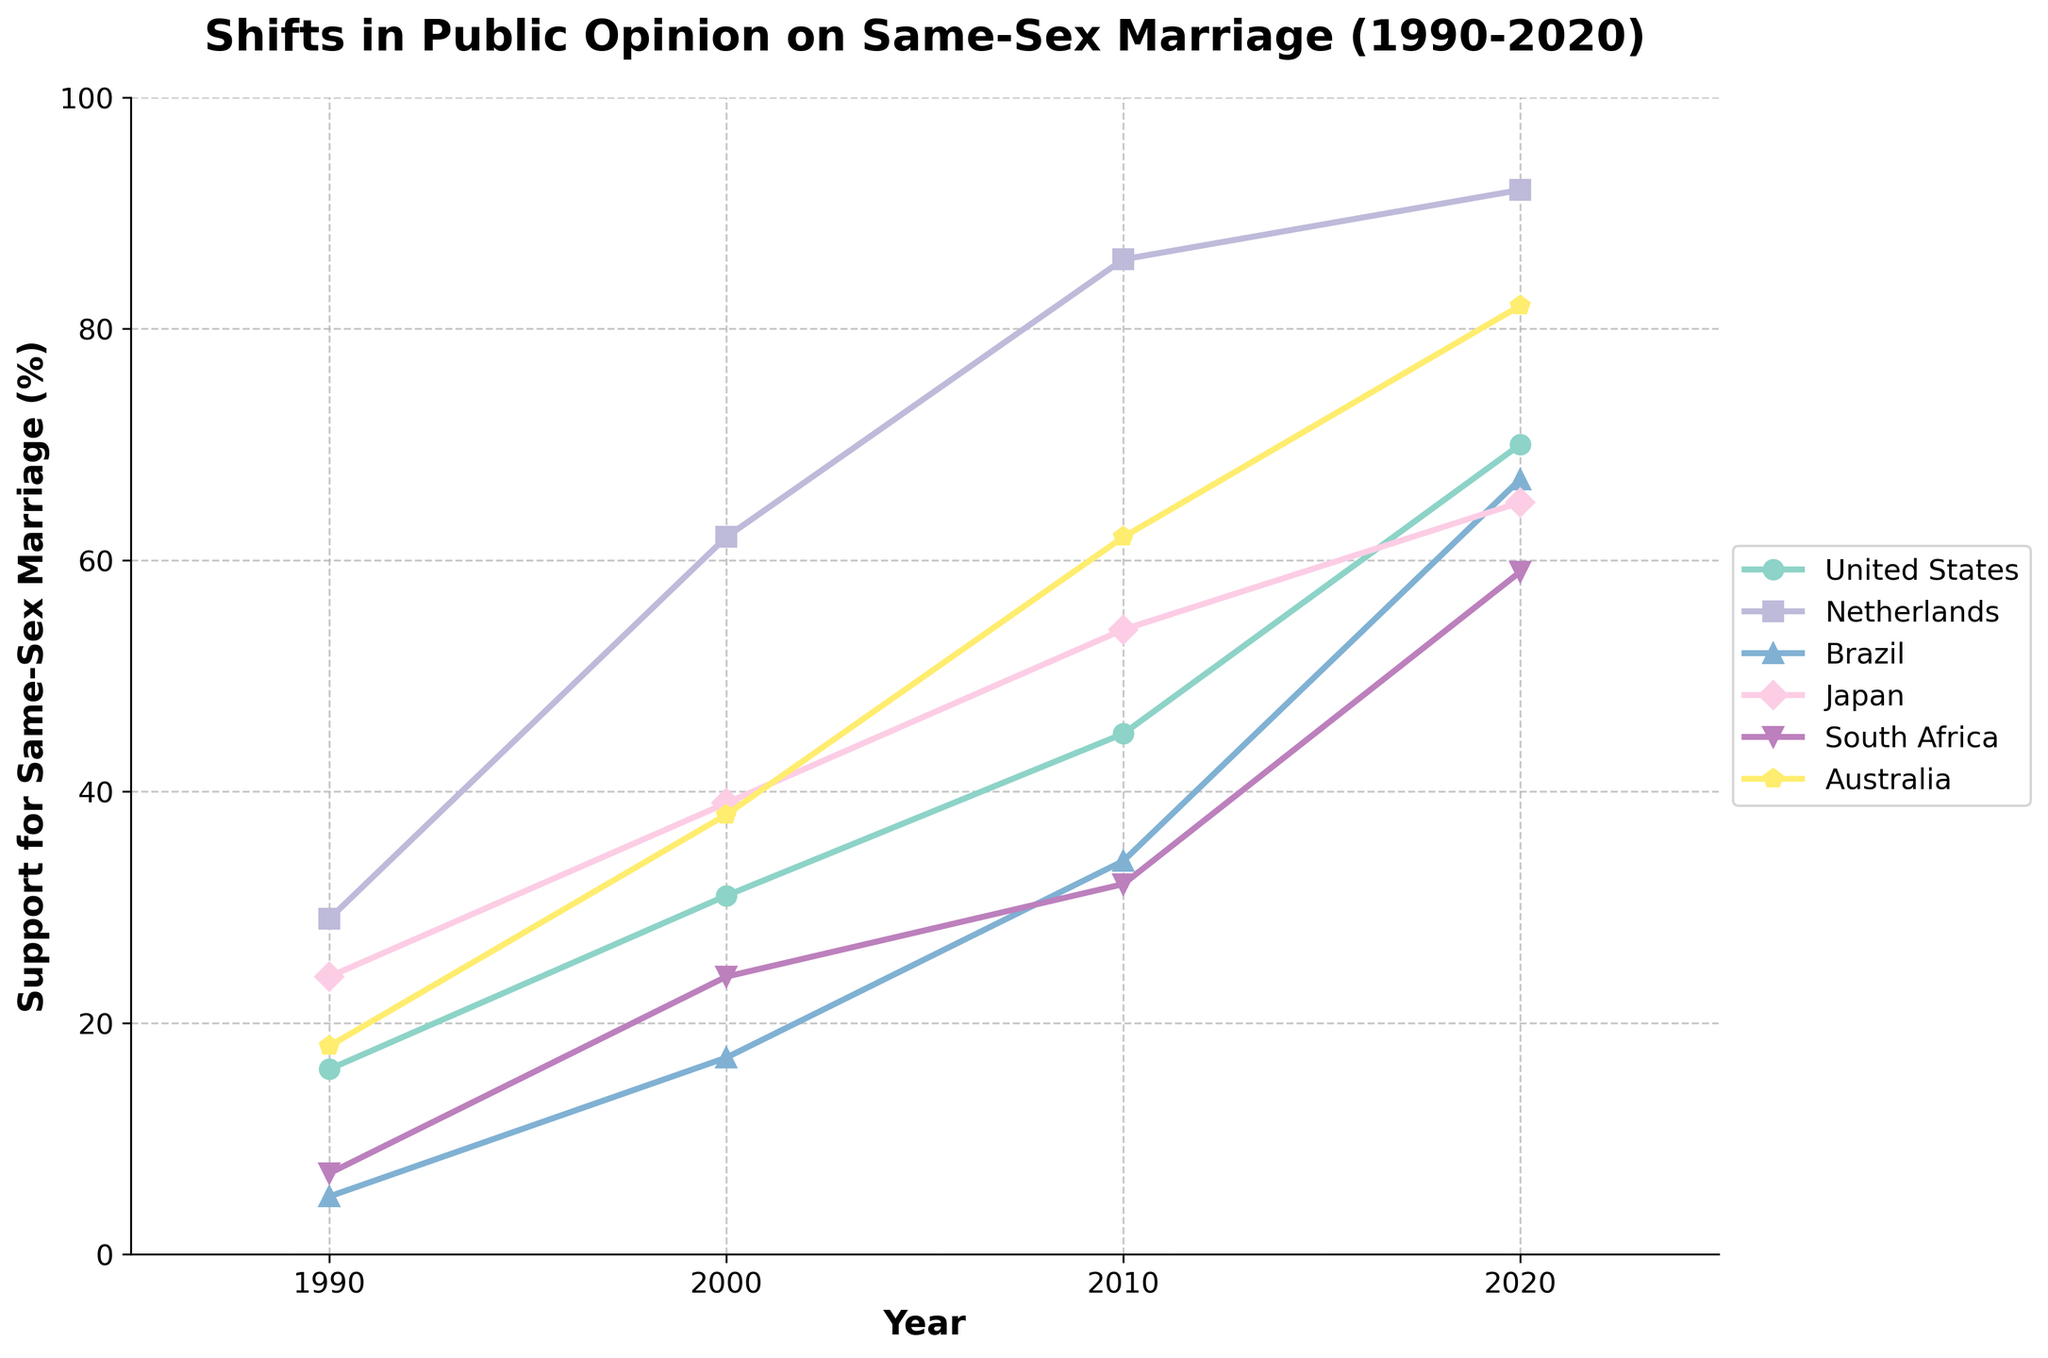What trends can you observe in the support for same-sex marriage in the United States from 1990 to 2020? The support for same-sex marriage in the United States has steadily increased from 16% in 1990 to 70% in 2020.
Answer: Steadily increased How does the 2020 support for same-sex marriage in Brazil compare to that in Australia? In 2020, Brazil's support for same-sex marriage is 67%, while Australia's support is 82%. Australia shows higher support for same-sex marriage than Brazil in 2020.
Answer: Australia shows higher support In which country did the support for same-sex marriage exceed 80% by 2020? By 2020, the support for same-sex marriage exceeded 80% only in the Netherlands and Australia, with 92% and 82%, respectively.
Answer: Netherlands and Australia How much did the support for same-sex marriage in Japan increase from 1990 to 2020? In Japan, the support for same-sex marriage increased from 24% in 1990 to 65% in 2020, an increase of 41%.
Answer: 41% Which country showed the smallest increase in support for same-sex marriage from 1990 to 2020? The smallest increase in support for same-sex marriage from 1990 to 2020 occurred in Japan, where it increased by 41% (from 24% to 65%).
Answer: Japan Is there any country where the support for same-sex marriage reached or exceeded 90% in 2020? Yes, in 2020, the support for same-sex marriage reached 92% in the Netherlands, exceeding 90%.
Answer: Netherlands Which country had the lowest initial support for same-sex marriage in 1990, and how much was it? Brazil had the lowest initial support for same-sex marriage in 1990, with only 5%.
Answer: Brazil (5%) Did the support for same-sex marriage in South Africa ever reach or exceed 60% by 2020? No, the support for same-sex marriage in South Africa did not reach or exceed 60% by 2020; it was at 59%.
Answer: No 